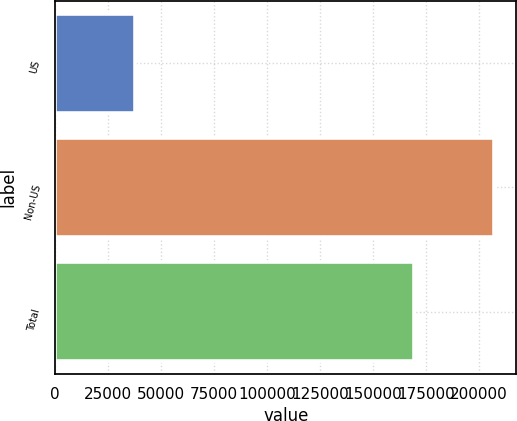Convert chart. <chart><loc_0><loc_0><loc_500><loc_500><bar_chart><fcel>US<fcel>Non-US<fcel>Total<nl><fcel>37758<fcel>207361<fcel>169603<nl></chart> 